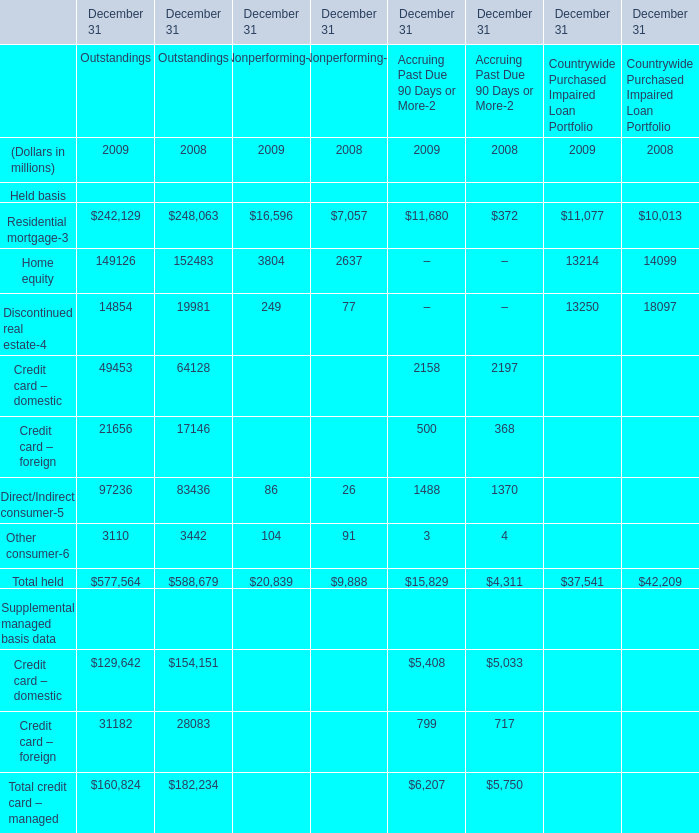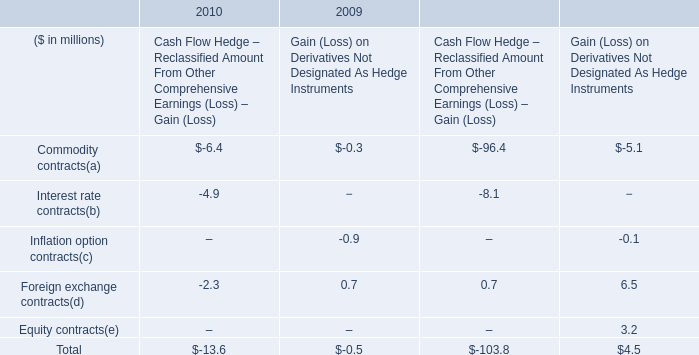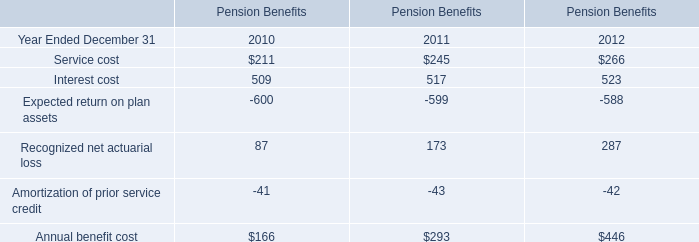What's the average of Home equity of Outstandings in 2009 and 2008? (in millions) 
Computations: ((149126 + 152483) / 2)
Answer: 150804.5. 